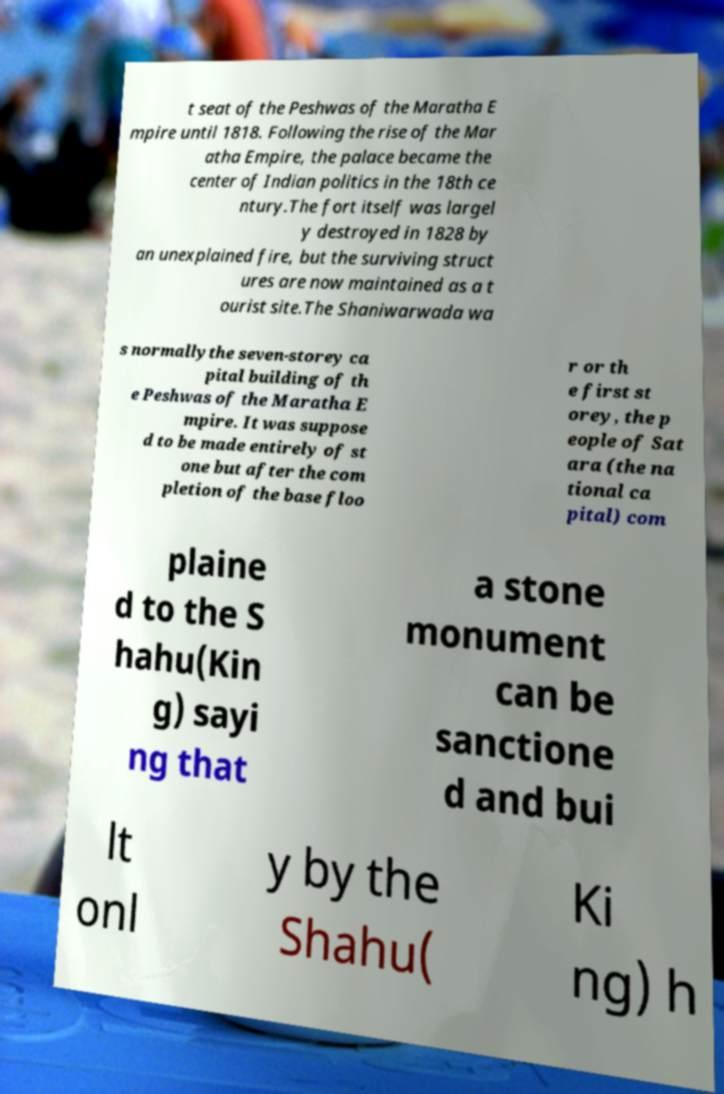Could you assist in decoding the text presented in this image and type it out clearly? t seat of the Peshwas of the Maratha E mpire until 1818. Following the rise of the Mar atha Empire, the palace became the center of Indian politics in the 18th ce ntury.The fort itself was largel y destroyed in 1828 by an unexplained fire, but the surviving struct ures are now maintained as a t ourist site.The Shaniwarwada wa s normallythe seven-storey ca pital building of th e Peshwas of the Maratha E mpire. It was suppose d to be made entirely of st one but after the com pletion of the base floo r or th e first st orey, the p eople of Sat ara (the na tional ca pital) com plaine d to the S hahu(Kin g) sayi ng that a stone monument can be sanctione d and bui lt onl y by the Shahu( Ki ng) h 